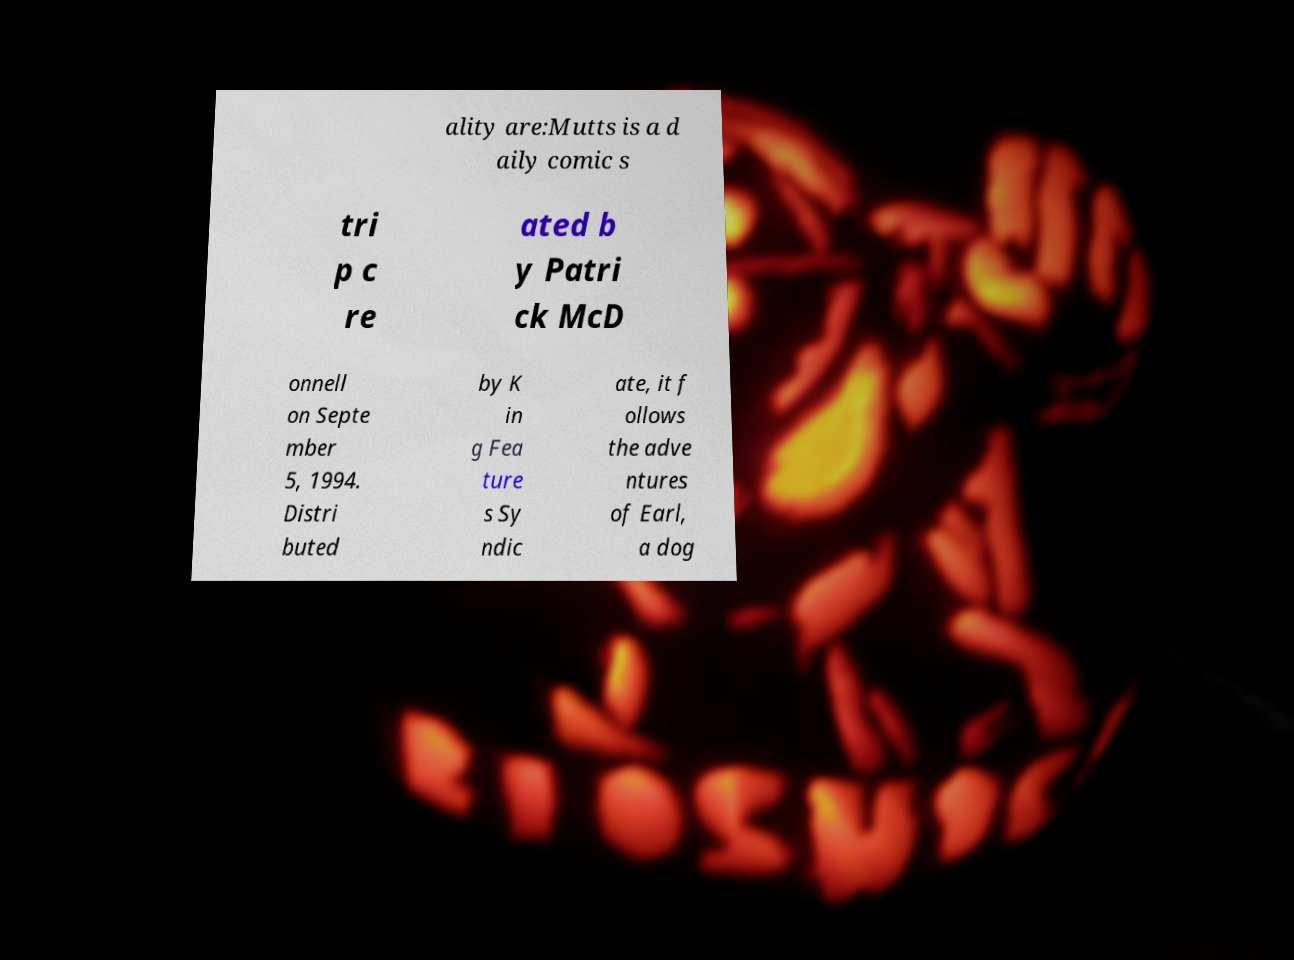Can you accurately transcribe the text from the provided image for me? ality are:Mutts is a d aily comic s tri p c re ated b y Patri ck McD onnell on Septe mber 5, 1994. Distri buted by K in g Fea ture s Sy ndic ate, it f ollows the adve ntures of Earl, a dog 